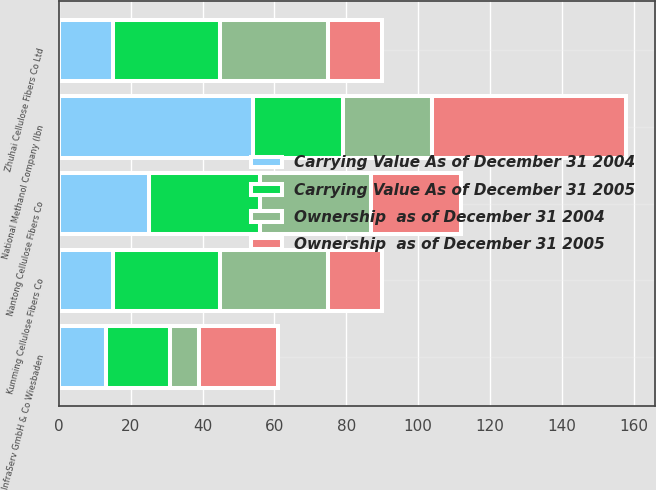Convert chart. <chart><loc_0><loc_0><loc_500><loc_500><stacked_bar_chart><ecel><fcel>National Methanol Company (Ibn<fcel>Kunming Cellulose Fibers Co<fcel>Nantong Cellulose Fibers Co<fcel>Zhuhai Cellulose Fibers Co Ltd<fcel>InfraServ GmbH & Co Wiesbaden<nl><fcel>Ownership  as of December 31 2004<fcel>25<fcel>30<fcel>31<fcel>30<fcel>8<nl><fcel>Carrying Value As of December 31 2005<fcel>25<fcel>30<fcel>31<fcel>30<fcel>18<nl><fcel>Carrying Value As of December 31 2004<fcel>54<fcel>15<fcel>25<fcel>15<fcel>13<nl><fcel>Ownership  as of December 31 2005<fcel>54<fcel>15<fcel>25<fcel>15<fcel>22<nl></chart> 